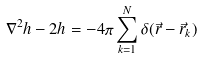<formula> <loc_0><loc_0><loc_500><loc_500>\nabla ^ { 2 } h - 2 h = - 4 \pi \sum _ { k = 1 } ^ { N } \delta ( { \vec { r } } - { \vec { r } _ { k } } )</formula> 